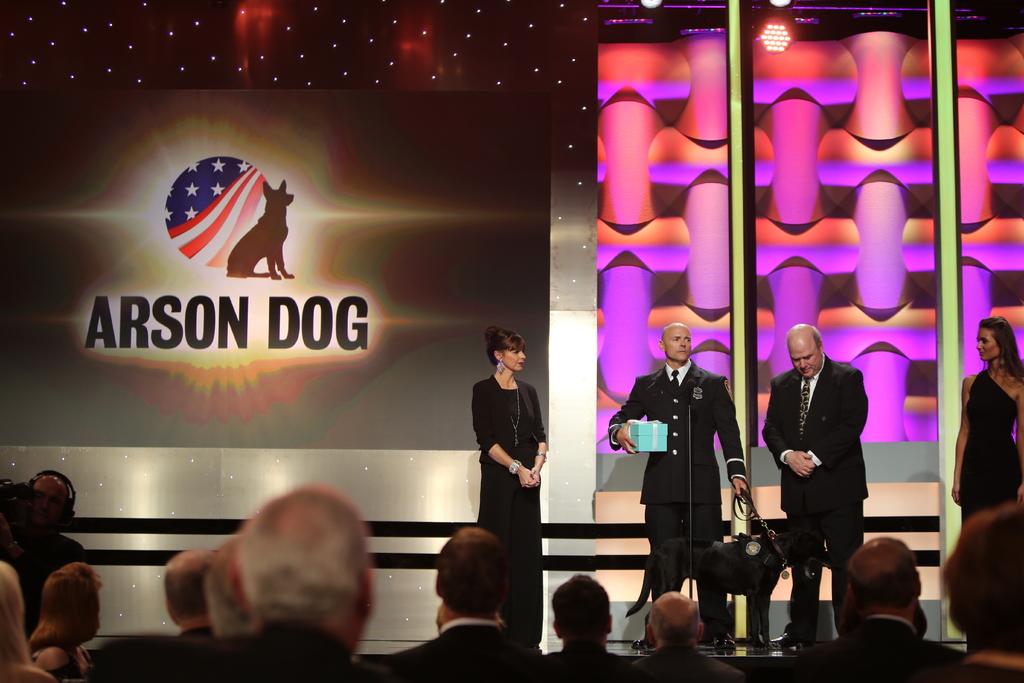Does this dog have experience with fires?
Your response must be concise. Yes. What type of dog?
Your response must be concise. Arson. 